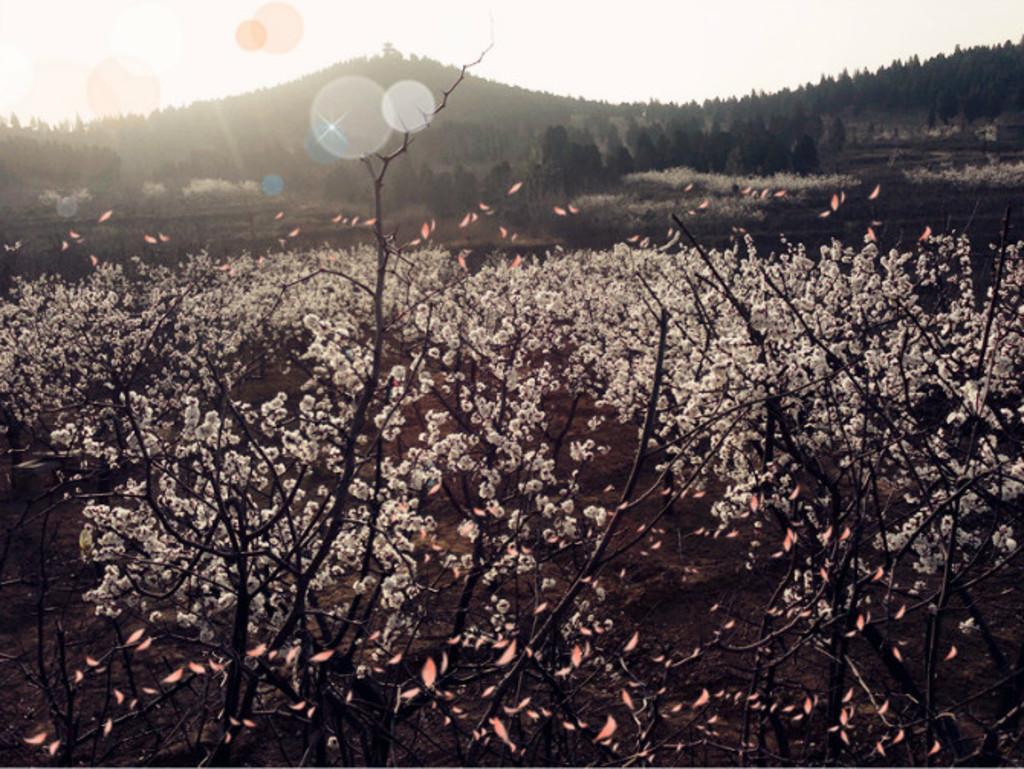Can you describe this image briefly? In this image there are plants in the foreground. There are trees and mountains in the background. And there is a sky at the top. 